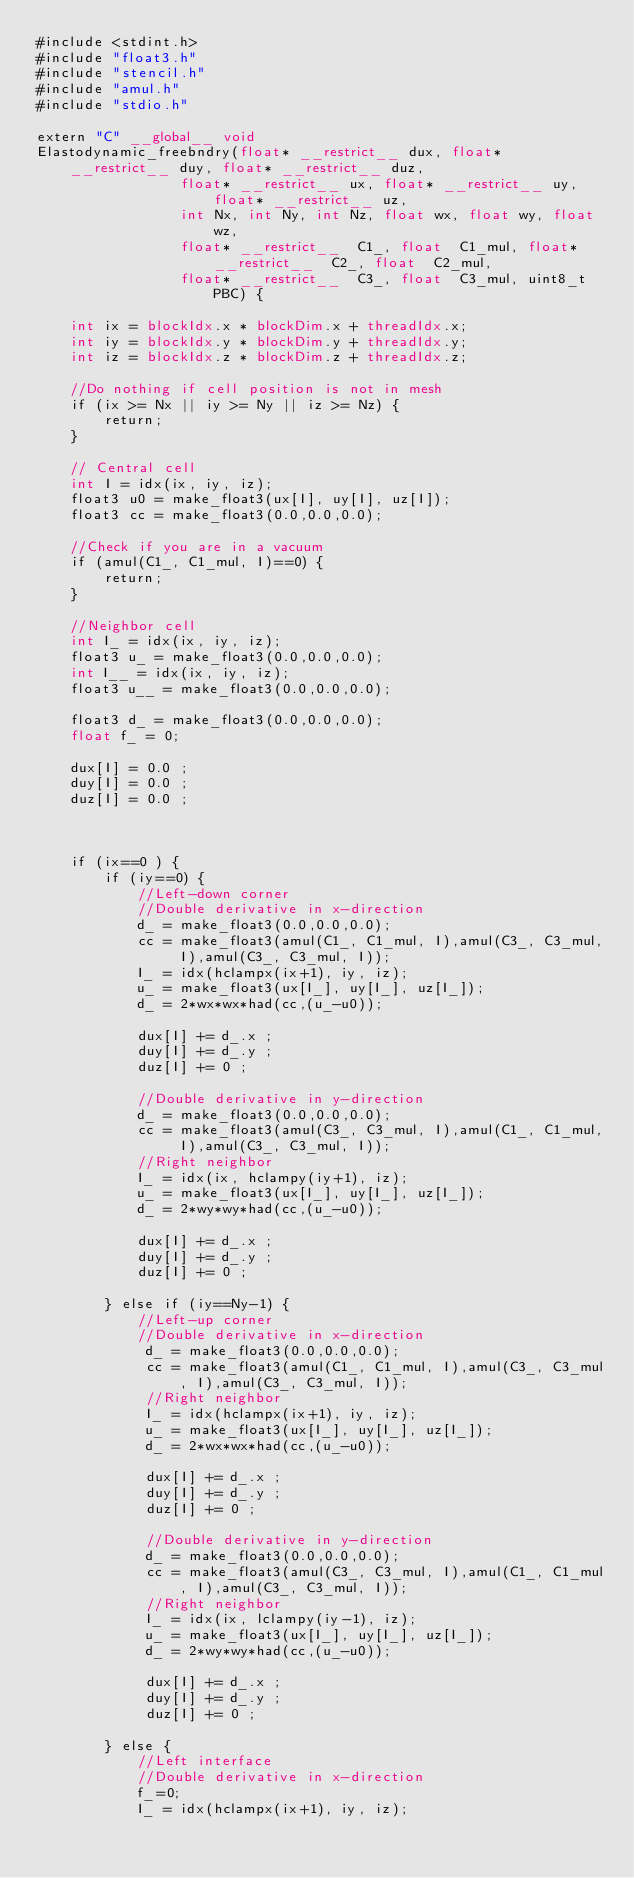<code> <loc_0><loc_0><loc_500><loc_500><_Cuda_>#include <stdint.h>
#include "float3.h"
#include "stencil.h"
#include "amul.h"
#include "stdio.h"

extern "C" __global__ void
Elastodynamic_freebndry(float* __restrict__ dux, float* __restrict__ duy, float* __restrict__ duz, 
                 float* __restrict__ ux, float* __restrict__ uy, float* __restrict__ uz,
                 int Nx, int Ny, int Nz, float wx, float wy, float wz, 
                 float* __restrict__  C1_, float  C1_mul, float* __restrict__  C2_, float  C2_mul, 
                 float* __restrict__  C3_, float  C3_mul, uint8_t PBC) {

    int ix = blockIdx.x * blockDim.x + threadIdx.x;
    int iy = blockIdx.y * blockDim.y + threadIdx.y;
    int iz = blockIdx.z * blockDim.z + threadIdx.z;

    //Do nothing if cell position is not in mesh
    if (ix >= Nx || iy >= Ny || iz >= Nz) {
        return;
    }

    // Central cell
    int I = idx(ix, iy, iz);
    float3 u0 = make_float3(ux[I], uy[I], uz[I]);
    float3 cc = make_float3(0.0,0.0,0.0);

    //Check if you are in a vacuum
    if (amul(C1_, C1_mul, I)==0) {
        return;
    }
    
    //Neighbor cell
    int I_ = idx(ix, iy, iz);
    float3 u_ = make_float3(0.0,0.0,0.0);
    int I__ = idx(ix, iy, iz);
    float3 u__ = make_float3(0.0,0.0,0.0);

    float3 d_ = make_float3(0.0,0.0,0.0);
    float f_ = 0;

    dux[I] = 0.0 ;
    duy[I] = 0.0 ;
    duz[I] = 0.0 ;



    if (ix==0 ) {
        if (iy==0) {
            //Left-down corner
            //Double derivative in x-direction
            d_ = make_float3(0.0,0.0,0.0);
            cc = make_float3(amul(C1_, C1_mul, I),amul(C3_, C3_mul, I),amul(C3_, C3_mul, I));
            I_ = idx(hclampx(ix+1), iy, iz);
            u_ = make_float3(ux[I_], uy[I_], uz[I_]);
            d_ = 2*wx*wx*had(cc,(u_-u0));
            
            dux[I] += d_.x ;
            duy[I] += d_.y ;
            duz[I] += 0 ;

            //Double derivative in y-direction
            d_ = make_float3(0.0,0.0,0.0);
            cc = make_float3(amul(C3_, C3_mul, I),amul(C1_, C1_mul, I),amul(C3_, C3_mul, I));
            //Right neighbor
            I_ = idx(ix, hclampy(iy+1), iz);
            u_ = make_float3(ux[I_], uy[I_], uz[I_]);
            d_ = 2*wy*wy*had(cc,(u_-u0));
            
            dux[I] += d_.x ;
            duy[I] += d_.y ;
            duz[I] += 0 ;

        } else if (iy==Ny-1) {
            //Left-up corner
            //Double derivative in x-direction
             d_ = make_float3(0.0,0.0,0.0);
             cc = make_float3(amul(C1_, C1_mul, I),amul(C3_, C3_mul, I),amul(C3_, C3_mul, I));
             //Right neighbor
             I_ = idx(hclampx(ix+1), iy, iz);
             u_ = make_float3(ux[I_], uy[I_], uz[I_]);
             d_ = 2*wx*wx*had(cc,(u_-u0));
             
             dux[I] += d_.x ;
             duy[I] += d_.y ;
             duz[I] += 0 ;
 
             //Double derivative in y-direction
             d_ = make_float3(0.0,0.0,0.0);
             cc = make_float3(amul(C3_, C3_mul, I),amul(C1_, C1_mul, I),amul(C3_, C3_mul, I));
             //Right neighbor
             I_ = idx(ix, lclampy(iy-1), iz);
             u_ = make_float3(ux[I_], uy[I_], uz[I_]);
             d_ = 2*wy*wy*had(cc,(u_-u0));
             
             dux[I] += d_.x ;
             duy[I] += d_.y ;
             duz[I] += 0 ;

        } else {
            //Left interface
            //Double derivative in x-direction
            f_=0;
            I_ = idx(hclampx(ix+1), iy, iz);</code> 